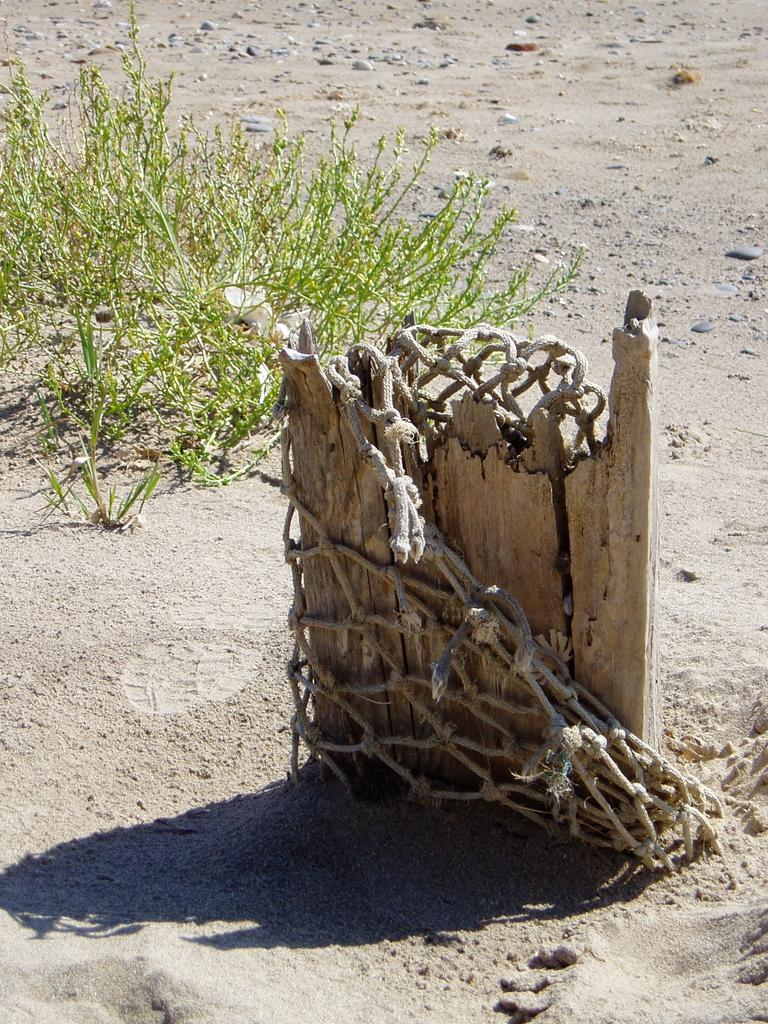What is the main feature in the foreground of the image? There is a truncated tree in the foreground of the image. What else can be seen in the foreground of the image? There is a net in the foreground of the image. What type of vegetation is visible in the background of the image? There are plants in the background of the image. What type of terrain is visible in the background of the image? There is sand visible in the background of the image. What type of wool can be seen being spun by the clam in the image? There is no wool or clam present in the image. How many boats are visible in the image? There are no boats visible in the image. 